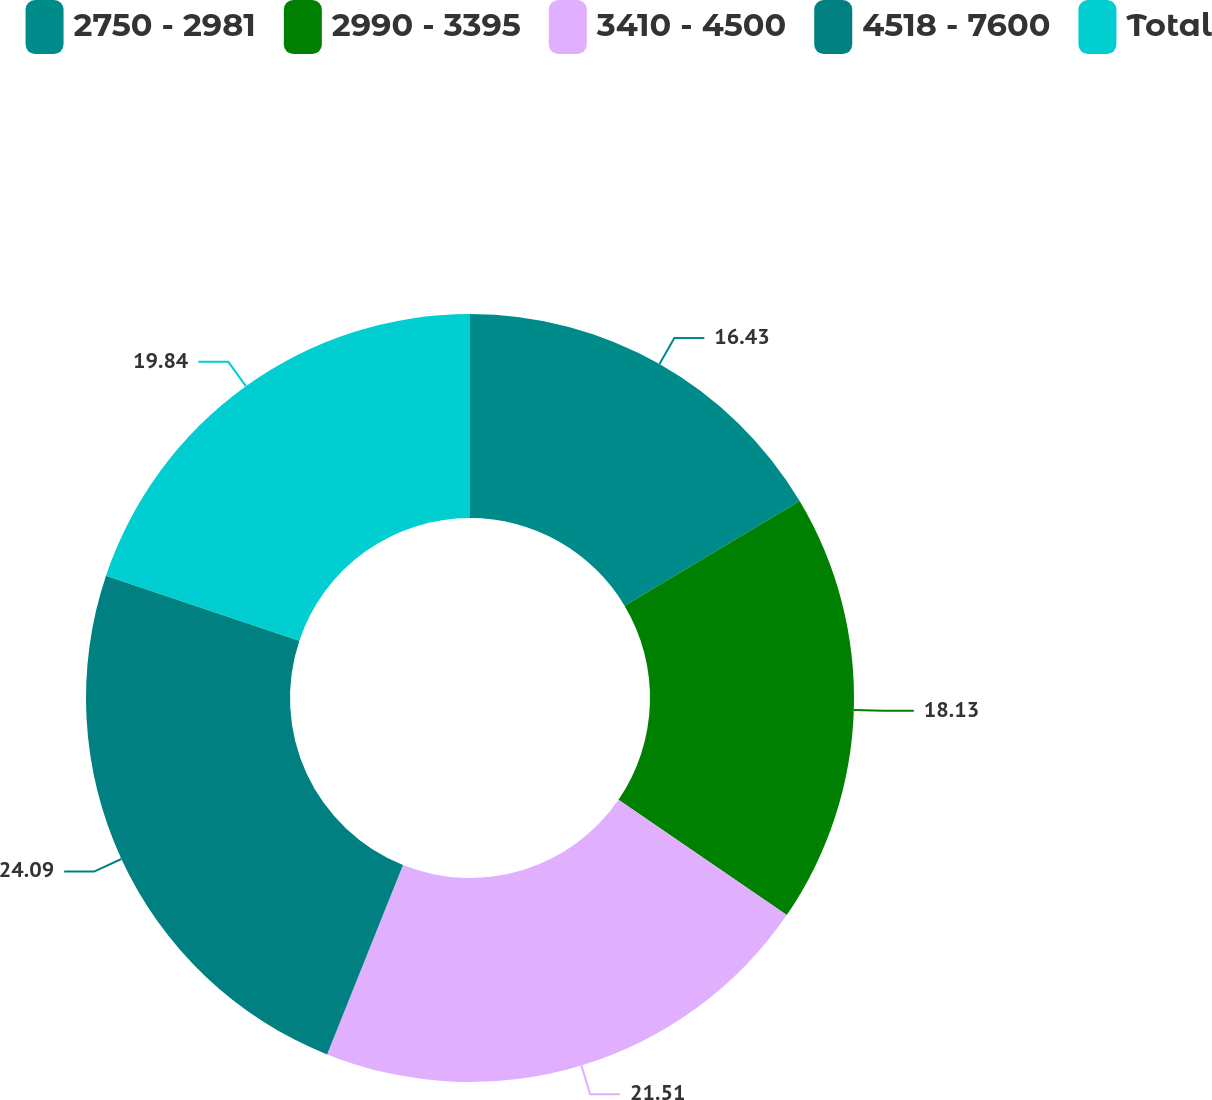Convert chart to OTSL. <chart><loc_0><loc_0><loc_500><loc_500><pie_chart><fcel>2750 - 2981<fcel>2990 - 3395<fcel>3410 - 4500<fcel>4518 - 7600<fcel>Total<nl><fcel>16.43%<fcel>18.13%<fcel>21.51%<fcel>24.09%<fcel>19.84%<nl></chart> 